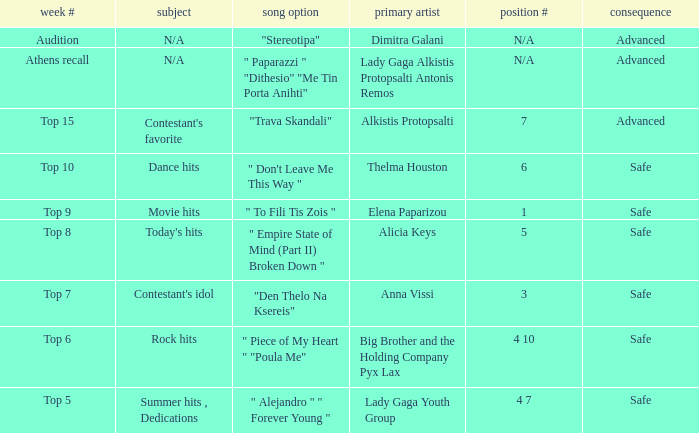What are all the order #s from the week "top 6"? 4 10. Could you parse the entire table? {'header': ['week #', 'subject', 'song option', 'primary artist', 'position #', 'consequence'], 'rows': [['Audition', 'N/A', '"Stereotipa"', 'Dimitra Galani', 'N/A', 'Advanced'], ['Athens recall', 'N/A', '" Paparazzi " "Dithesio" "Me Tin Porta Anihti"', 'Lady Gaga Alkistis Protopsalti Antonis Remos', 'N/A', 'Advanced'], ['Top 15', "Contestant's favorite", '"Trava Skandali"', 'Alkistis Protopsalti', '7', 'Advanced'], ['Top 10', 'Dance hits', '" Don\'t Leave Me This Way "', 'Thelma Houston', '6', 'Safe'], ['Top 9', 'Movie hits', '" To Fili Tis Zois "', 'Elena Paparizou', '1', 'Safe'], ['Top 8', "Today's hits", '" Empire State of Mind (Part II) Broken Down "', 'Alicia Keys', '5', 'Safe'], ['Top 7', "Contestant's idol", '"Den Thelo Na Ksereis"', 'Anna Vissi', '3', 'Safe'], ['Top 6', 'Rock hits', '" Piece of My Heart " "Poula Me"', 'Big Brother and the Holding Company Pyx Lax', '4 10', 'Safe'], ['Top 5', 'Summer hits , Dedications', '" Alejandro " " Forever Young "', 'Lady Gaga Youth Group', '4 7', 'Safe']]} 